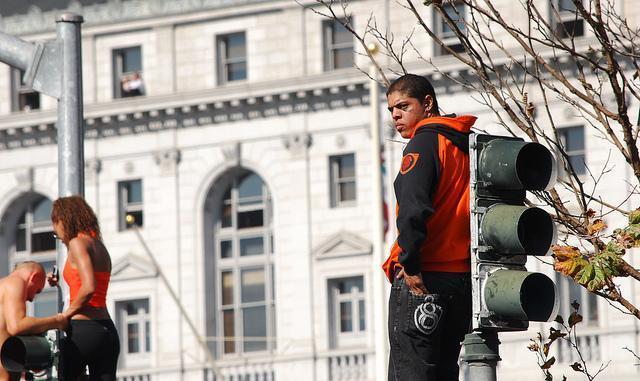How many people are in the picture?
Give a very brief answer. 3. How many little elephants are in the image?
Give a very brief answer. 0. 